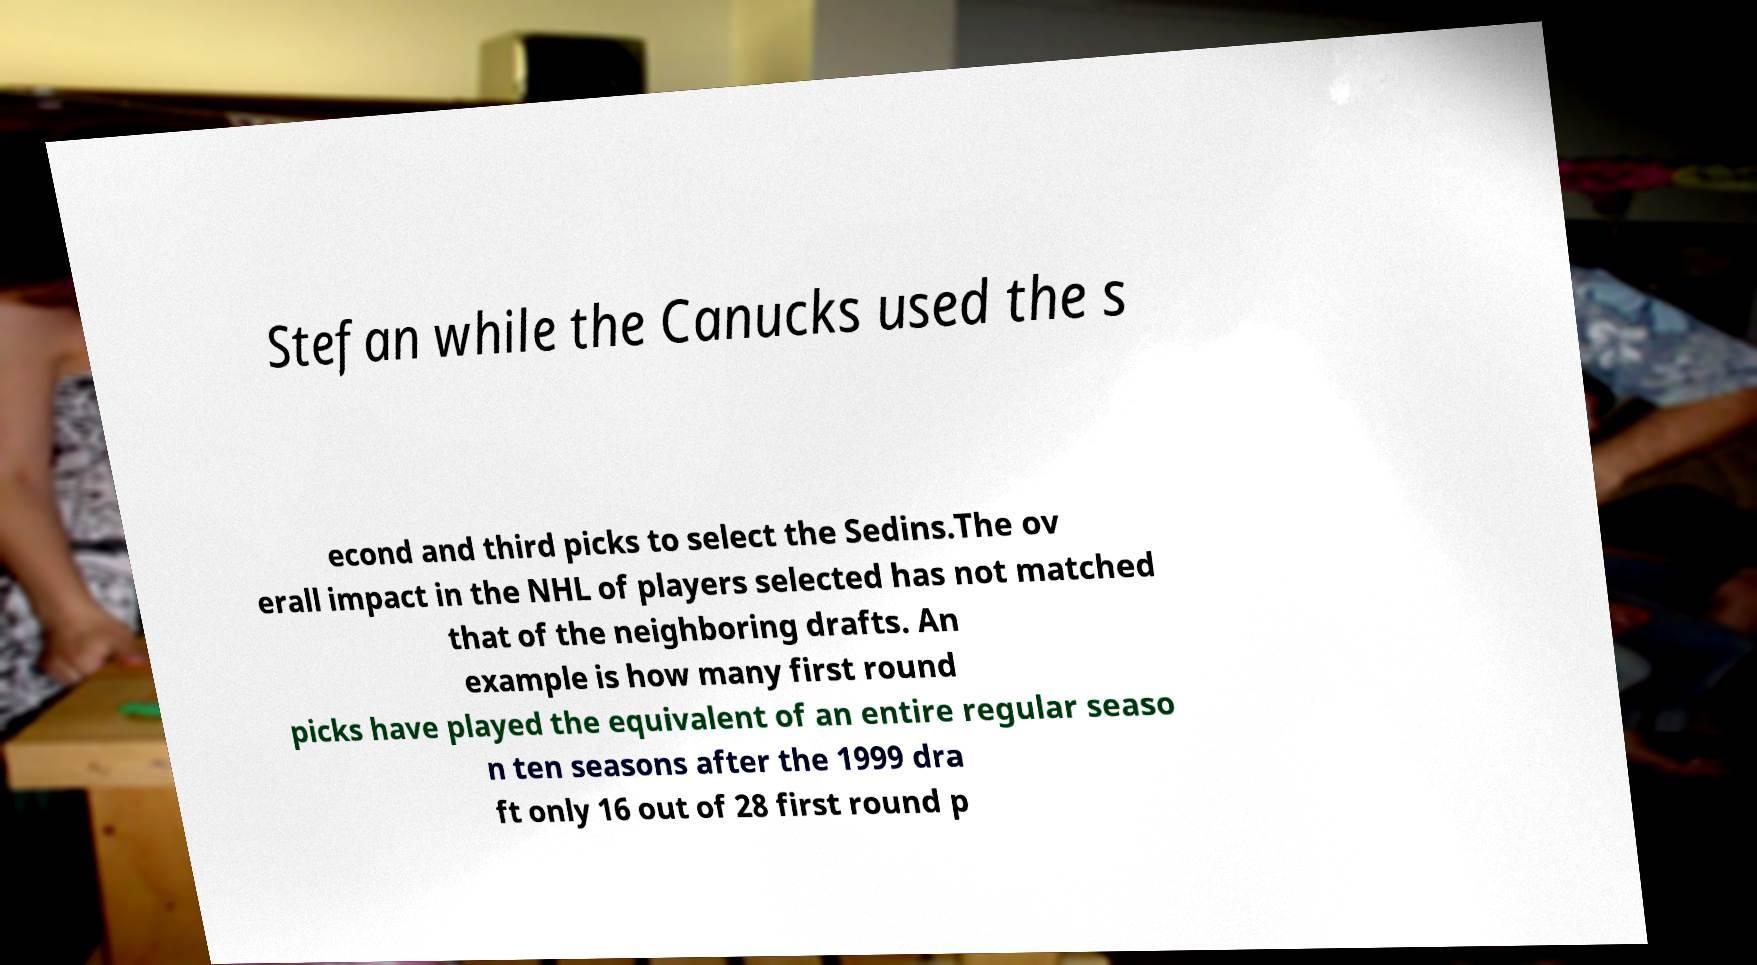Can you read and provide the text displayed in the image?This photo seems to have some interesting text. Can you extract and type it out for me? Stefan while the Canucks used the s econd and third picks to select the Sedins.The ov erall impact in the NHL of players selected has not matched that of the neighboring drafts. An example is how many first round picks have played the equivalent of an entire regular seaso n ten seasons after the 1999 dra ft only 16 out of 28 first round p 